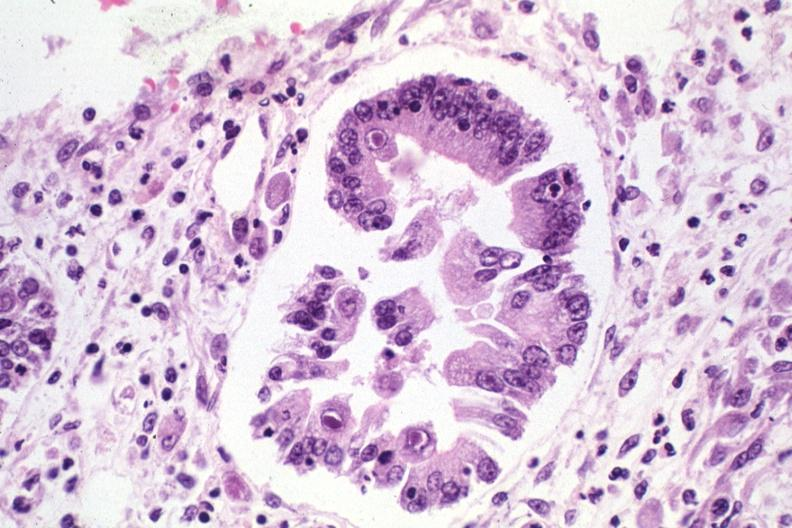s stomach present?
Answer the question using a single word or phrase. Yes 